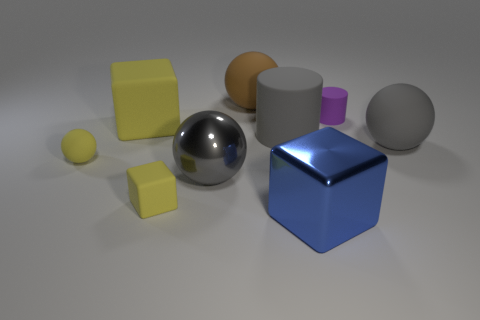How does the lighting in the scene affect the appearance of the objects? The lighting in the scene is soft and diffused, coming from above. It creates subtle shadows that enhance the three-dimensionality of the objects. The reflective surfaces of the metal objects catch the light and produce highlights that emphasize their shiny texture, while the matte objects absorb the light, minimizing reflections. 